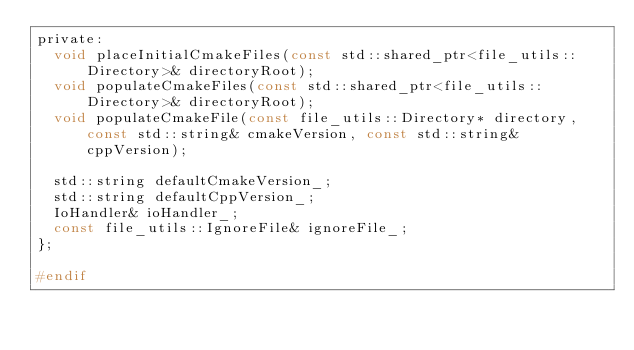<code> <loc_0><loc_0><loc_500><loc_500><_C_>private:
  void placeInitialCmakeFiles(const std::shared_ptr<file_utils::Directory>& directoryRoot);
  void populateCmakeFiles(const std::shared_ptr<file_utils::Directory>& directoryRoot);
  void populateCmakeFile(const file_utils::Directory* directory, const std::string& cmakeVersion, const std::string& cppVersion);

  std::string defaultCmakeVersion_;
  std::string defaultCppVersion_;
  IoHandler& ioHandler_;
  const file_utils::IgnoreFile& ignoreFile_;
};

#endif</code> 